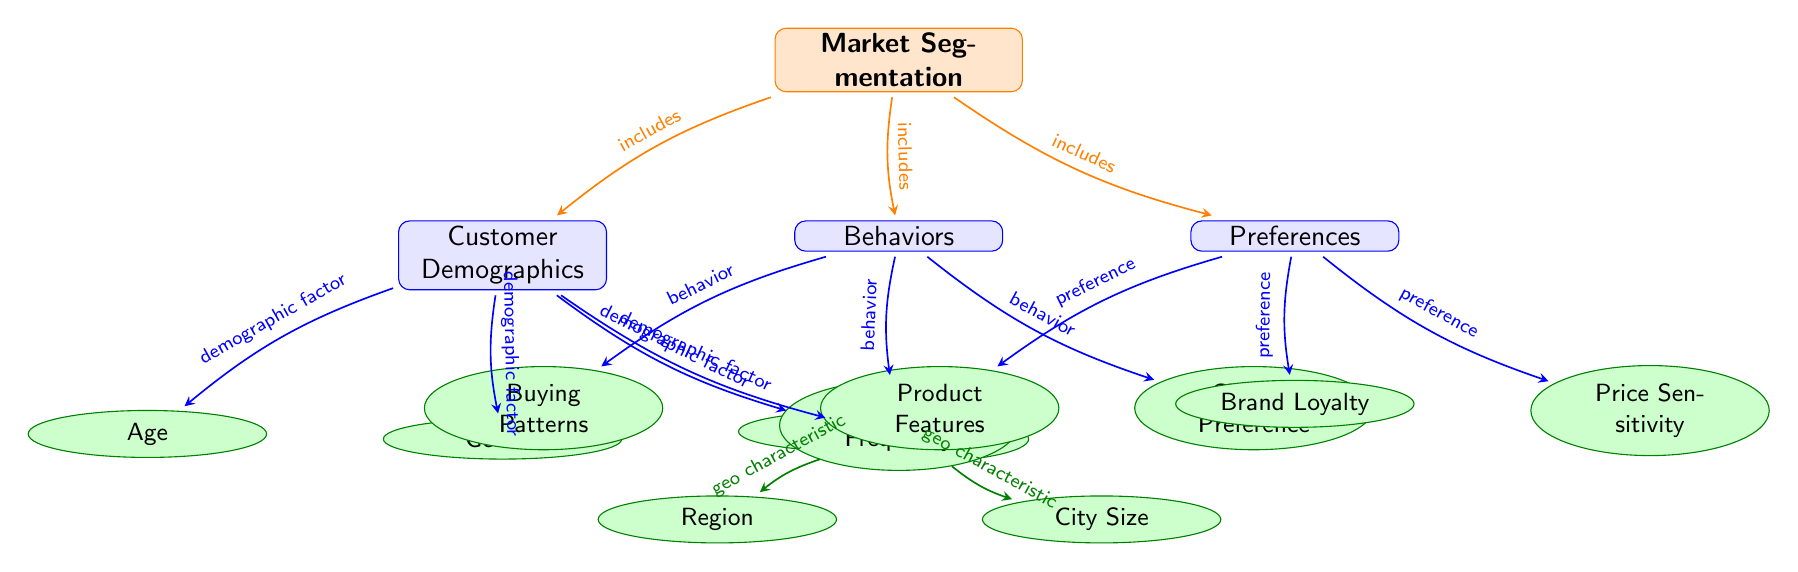What are the three main categories of market segmentation? The three main categories are Customer Demographics, Behaviors, and Preferences, which are the primary divisions in the visual representation of market segmentation.
Answer: Customer Demographics, Behaviors, Preferences How many detail items are related to Customer Demographics? The detail items under Customer Demographics are Age, Gender, Income, and Geographic, amounting to a total of four items.
Answer: 4 Which detail item falls under Behaviors? Buying Patterns is a detail item listed directly under the Behaviors category in the diagram.
Answer: Buying Patterns What demographic factor is related to Geographic characteristics? The Geographic node has two associated detail items, Region and City Size, indicating demographic factors that consider geographic characteristics.
Answer: Region, City Size What do Product Features, Brand Loyalty, and Price Sensitivity represent? These three items are specific preferences that fall under the Preferences category, indicating what customers prioritize when buying a product.
Answer: Product Features, Brand Loyalty, Price Sensitivity How does Age relate to Market Segmentation? Age is categorized as a demographic factor under the Customer Demographics section, showing its importance in market segmentation analysis.
Answer: Demographic factor Which category includes Usage Frequency? The Usage Frequency detail item is listed under the Behaviors category, suggesting its relevance to understanding customer actions and habits in the market.
Answer: Behaviors What is the relationship between Market Segmentation and Customer Demographics? Market Segmentation includes Customer Demographics as one of its primary components, as indicated by the edge labeled "includes" connecting the two nodes in the diagram.
Answer: includes 